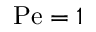<formula> <loc_0><loc_0><loc_500><loc_500>P e = 1</formula> 